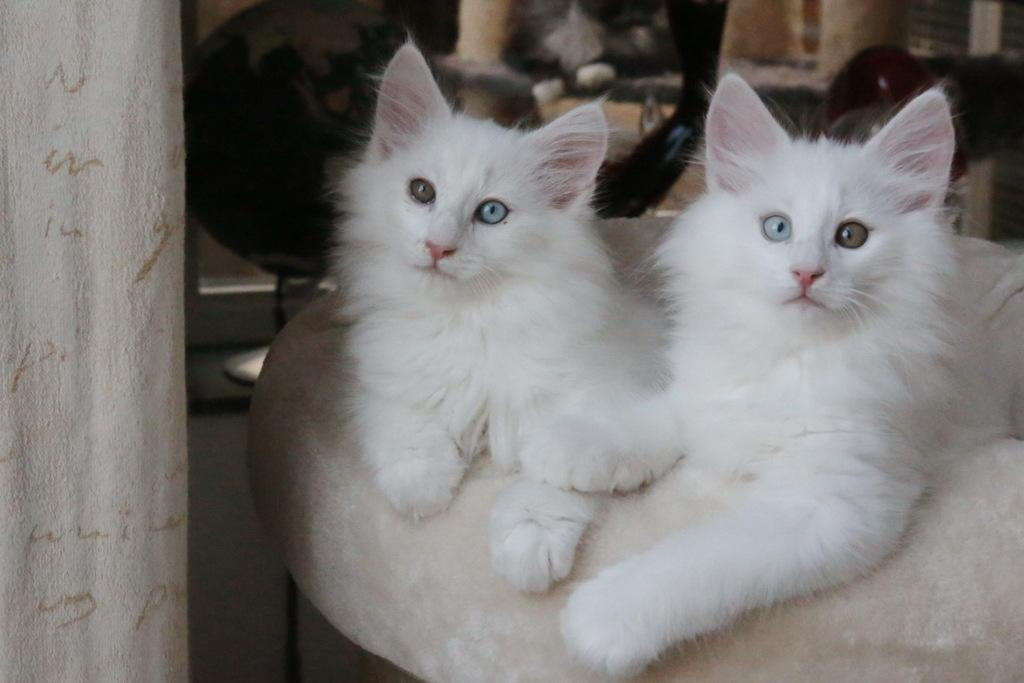How many cats are in the image? There are two cats in the image. What color are the cats? The cats are white in color. What type of surface are the cats on? The cats are on a cream and white color surface. What can be seen in the background of the image? There are objects visible in the background of the image. What type of bread is the stranger holding in the image? There is no stranger or bread present in the image; it features two white cats on a cream and white color surface. 